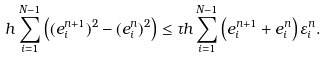Convert formula to latex. <formula><loc_0><loc_0><loc_500><loc_500>h \sum _ { i = 1 } ^ { N - 1 } \left ( ( e _ { i } ^ { n + 1 } ) ^ { 2 } - ( e _ { i } ^ { n } ) ^ { 2 } \right ) \leq \tau h \sum _ { i = 1 } ^ { N - 1 } \left ( e _ { i } ^ { n + 1 } + e _ { i } ^ { n } \right ) \varepsilon _ { i } ^ { n } .</formula> 